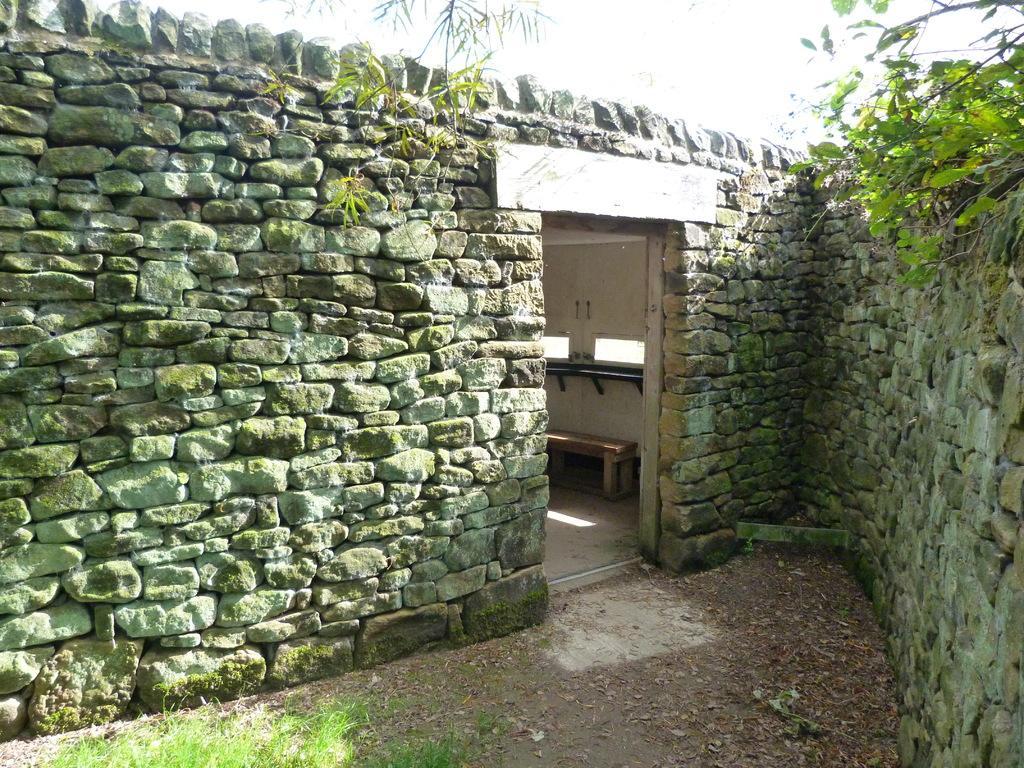How would you summarize this image in a sentence or two? In this picture there is a stone wall which is in V shape. On the stone wall, there is a door, inside it there is a bench. On the wall, there are some plants. 